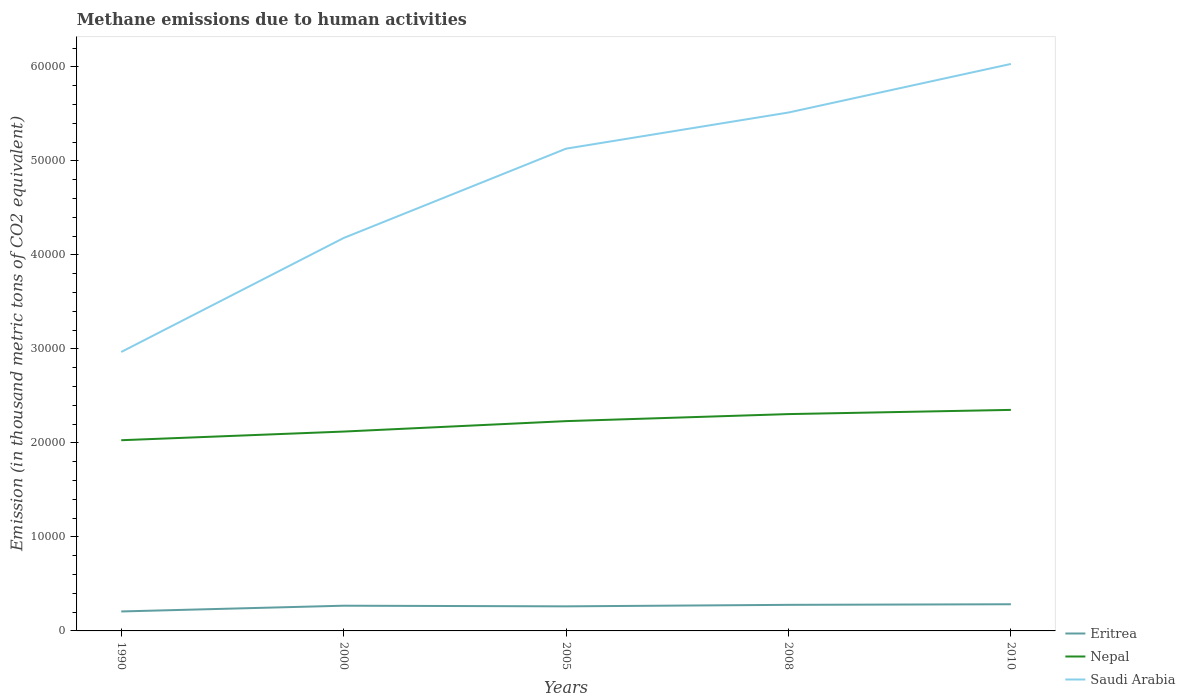How many different coloured lines are there?
Your answer should be compact. 3. Is the number of lines equal to the number of legend labels?
Your answer should be very brief. Yes. Across all years, what is the maximum amount of methane emitted in Eritrea?
Keep it short and to the point. 2070.6. What is the total amount of methane emitted in Saudi Arabia in the graph?
Provide a succinct answer. -1.21e+04. What is the difference between the highest and the second highest amount of methane emitted in Nepal?
Provide a succinct answer. 3226.3. What is the difference between the highest and the lowest amount of methane emitted in Eritrea?
Your answer should be very brief. 4. How many lines are there?
Your response must be concise. 3. What is the difference between two consecutive major ticks on the Y-axis?
Provide a succinct answer. 10000. Does the graph contain any zero values?
Provide a short and direct response. No. How many legend labels are there?
Ensure brevity in your answer.  3. How are the legend labels stacked?
Provide a short and direct response. Vertical. What is the title of the graph?
Make the answer very short. Methane emissions due to human activities. Does "Senegal" appear as one of the legend labels in the graph?
Your answer should be compact. No. What is the label or title of the Y-axis?
Provide a succinct answer. Emission (in thousand metric tons of CO2 equivalent). What is the Emission (in thousand metric tons of CO2 equivalent) in Eritrea in 1990?
Ensure brevity in your answer.  2070.6. What is the Emission (in thousand metric tons of CO2 equivalent) of Nepal in 1990?
Your answer should be compact. 2.03e+04. What is the Emission (in thousand metric tons of CO2 equivalent) of Saudi Arabia in 1990?
Your answer should be very brief. 2.97e+04. What is the Emission (in thousand metric tons of CO2 equivalent) in Eritrea in 2000?
Offer a very short reply. 2682.3. What is the Emission (in thousand metric tons of CO2 equivalent) in Nepal in 2000?
Offer a very short reply. 2.12e+04. What is the Emission (in thousand metric tons of CO2 equivalent) in Saudi Arabia in 2000?
Give a very brief answer. 4.18e+04. What is the Emission (in thousand metric tons of CO2 equivalent) of Eritrea in 2005?
Make the answer very short. 2613.6. What is the Emission (in thousand metric tons of CO2 equivalent) in Nepal in 2005?
Your answer should be very brief. 2.23e+04. What is the Emission (in thousand metric tons of CO2 equivalent) of Saudi Arabia in 2005?
Offer a terse response. 5.13e+04. What is the Emission (in thousand metric tons of CO2 equivalent) of Eritrea in 2008?
Ensure brevity in your answer.  2774.7. What is the Emission (in thousand metric tons of CO2 equivalent) in Nepal in 2008?
Offer a terse response. 2.31e+04. What is the Emission (in thousand metric tons of CO2 equivalent) of Saudi Arabia in 2008?
Your answer should be compact. 5.51e+04. What is the Emission (in thousand metric tons of CO2 equivalent) in Eritrea in 2010?
Offer a very short reply. 2837. What is the Emission (in thousand metric tons of CO2 equivalent) in Nepal in 2010?
Your response must be concise. 2.35e+04. What is the Emission (in thousand metric tons of CO2 equivalent) of Saudi Arabia in 2010?
Your answer should be compact. 6.03e+04. Across all years, what is the maximum Emission (in thousand metric tons of CO2 equivalent) in Eritrea?
Provide a short and direct response. 2837. Across all years, what is the maximum Emission (in thousand metric tons of CO2 equivalent) in Nepal?
Your answer should be compact. 2.35e+04. Across all years, what is the maximum Emission (in thousand metric tons of CO2 equivalent) in Saudi Arabia?
Give a very brief answer. 6.03e+04. Across all years, what is the minimum Emission (in thousand metric tons of CO2 equivalent) in Eritrea?
Ensure brevity in your answer.  2070.6. Across all years, what is the minimum Emission (in thousand metric tons of CO2 equivalent) in Nepal?
Keep it short and to the point. 2.03e+04. Across all years, what is the minimum Emission (in thousand metric tons of CO2 equivalent) in Saudi Arabia?
Your answer should be compact. 2.97e+04. What is the total Emission (in thousand metric tons of CO2 equivalent) of Eritrea in the graph?
Make the answer very short. 1.30e+04. What is the total Emission (in thousand metric tons of CO2 equivalent) in Nepal in the graph?
Make the answer very short. 1.10e+05. What is the total Emission (in thousand metric tons of CO2 equivalent) of Saudi Arabia in the graph?
Your answer should be very brief. 2.38e+05. What is the difference between the Emission (in thousand metric tons of CO2 equivalent) in Eritrea in 1990 and that in 2000?
Provide a short and direct response. -611.7. What is the difference between the Emission (in thousand metric tons of CO2 equivalent) in Nepal in 1990 and that in 2000?
Offer a very short reply. -920.3. What is the difference between the Emission (in thousand metric tons of CO2 equivalent) of Saudi Arabia in 1990 and that in 2000?
Offer a terse response. -1.21e+04. What is the difference between the Emission (in thousand metric tons of CO2 equivalent) of Eritrea in 1990 and that in 2005?
Make the answer very short. -543. What is the difference between the Emission (in thousand metric tons of CO2 equivalent) in Nepal in 1990 and that in 2005?
Provide a succinct answer. -2031.1. What is the difference between the Emission (in thousand metric tons of CO2 equivalent) of Saudi Arabia in 1990 and that in 2005?
Give a very brief answer. -2.16e+04. What is the difference between the Emission (in thousand metric tons of CO2 equivalent) in Eritrea in 1990 and that in 2008?
Keep it short and to the point. -704.1. What is the difference between the Emission (in thousand metric tons of CO2 equivalent) of Nepal in 1990 and that in 2008?
Give a very brief answer. -2778.1. What is the difference between the Emission (in thousand metric tons of CO2 equivalent) of Saudi Arabia in 1990 and that in 2008?
Provide a short and direct response. -2.55e+04. What is the difference between the Emission (in thousand metric tons of CO2 equivalent) of Eritrea in 1990 and that in 2010?
Keep it short and to the point. -766.4. What is the difference between the Emission (in thousand metric tons of CO2 equivalent) in Nepal in 1990 and that in 2010?
Give a very brief answer. -3226.3. What is the difference between the Emission (in thousand metric tons of CO2 equivalent) of Saudi Arabia in 1990 and that in 2010?
Your answer should be compact. -3.06e+04. What is the difference between the Emission (in thousand metric tons of CO2 equivalent) in Eritrea in 2000 and that in 2005?
Ensure brevity in your answer.  68.7. What is the difference between the Emission (in thousand metric tons of CO2 equivalent) in Nepal in 2000 and that in 2005?
Provide a succinct answer. -1110.8. What is the difference between the Emission (in thousand metric tons of CO2 equivalent) of Saudi Arabia in 2000 and that in 2005?
Ensure brevity in your answer.  -9501.6. What is the difference between the Emission (in thousand metric tons of CO2 equivalent) in Eritrea in 2000 and that in 2008?
Make the answer very short. -92.4. What is the difference between the Emission (in thousand metric tons of CO2 equivalent) of Nepal in 2000 and that in 2008?
Ensure brevity in your answer.  -1857.8. What is the difference between the Emission (in thousand metric tons of CO2 equivalent) of Saudi Arabia in 2000 and that in 2008?
Offer a terse response. -1.33e+04. What is the difference between the Emission (in thousand metric tons of CO2 equivalent) in Eritrea in 2000 and that in 2010?
Offer a terse response. -154.7. What is the difference between the Emission (in thousand metric tons of CO2 equivalent) in Nepal in 2000 and that in 2010?
Offer a terse response. -2306. What is the difference between the Emission (in thousand metric tons of CO2 equivalent) in Saudi Arabia in 2000 and that in 2010?
Give a very brief answer. -1.85e+04. What is the difference between the Emission (in thousand metric tons of CO2 equivalent) in Eritrea in 2005 and that in 2008?
Your response must be concise. -161.1. What is the difference between the Emission (in thousand metric tons of CO2 equivalent) of Nepal in 2005 and that in 2008?
Provide a short and direct response. -747. What is the difference between the Emission (in thousand metric tons of CO2 equivalent) of Saudi Arabia in 2005 and that in 2008?
Give a very brief answer. -3844.6. What is the difference between the Emission (in thousand metric tons of CO2 equivalent) in Eritrea in 2005 and that in 2010?
Offer a terse response. -223.4. What is the difference between the Emission (in thousand metric tons of CO2 equivalent) in Nepal in 2005 and that in 2010?
Offer a terse response. -1195.2. What is the difference between the Emission (in thousand metric tons of CO2 equivalent) in Saudi Arabia in 2005 and that in 2010?
Your answer should be compact. -9011.1. What is the difference between the Emission (in thousand metric tons of CO2 equivalent) in Eritrea in 2008 and that in 2010?
Your response must be concise. -62.3. What is the difference between the Emission (in thousand metric tons of CO2 equivalent) in Nepal in 2008 and that in 2010?
Your answer should be compact. -448.2. What is the difference between the Emission (in thousand metric tons of CO2 equivalent) in Saudi Arabia in 2008 and that in 2010?
Make the answer very short. -5166.5. What is the difference between the Emission (in thousand metric tons of CO2 equivalent) in Eritrea in 1990 and the Emission (in thousand metric tons of CO2 equivalent) in Nepal in 2000?
Give a very brief answer. -1.91e+04. What is the difference between the Emission (in thousand metric tons of CO2 equivalent) of Eritrea in 1990 and the Emission (in thousand metric tons of CO2 equivalent) of Saudi Arabia in 2000?
Ensure brevity in your answer.  -3.97e+04. What is the difference between the Emission (in thousand metric tons of CO2 equivalent) of Nepal in 1990 and the Emission (in thousand metric tons of CO2 equivalent) of Saudi Arabia in 2000?
Your response must be concise. -2.15e+04. What is the difference between the Emission (in thousand metric tons of CO2 equivalent) in Eritrea in 1990 and the Emission (in thousand metric tons of CO2 equivalent) in Nepal in 2005?
Offer a terse response. -2.02e+04. What is the difference between the Emission (in thousand metric tons of CO2 equivalent) of Eritrea in 1990 and the Emission (in thousand metric tons of CO2 equivalent) of Saudi Arabia in 2005?
Keep it short and to the point. -4.92e+04. What is the difference between the Emission (in thousand metric tons of CO2 equivalent) in Nepal in 1990 and the Emission (in thousand metric tons of CO2 equivalent) in Saudi Arabia in 2005?
Provide a succinct answer. -3.10e+04. What is the difference between the Emission (in thousand metric tons of CO2 equivalent) in Eritrea in 1990 and the Emission (in thousand metric tons of CO2 equivalent) in Nepal in 2008?
Make the answer very short. -2.10e+04. What is the difference between the Emission (in thousand metric tons of CO2 equivalent) of Eritrea in 1990 and the Emission (in thousand metric tons of CO2 equivalent) of Saudi Arabia in 2008?
Your answer should be compact. -5.31e+04. What is the difference between the Emission (in thousand metric tons of CO2 equivalent) of Nepal in 1990 and the Emission (in thousand metric tons of CO2 equivalent) of Saudi Arabia in 2008?
Keep it short and to the point. -3.49e+04. What is the difference between the Emission (in thousand metric tons of CO2 equivalent) in Eritrea in 1990 and the Emission (in thousand metric tons of CO2 equivalent) in Nepal in 2010?
Ensure brevity in your answer.  -2.14e+04. What is the difference between the Emission (in thousand metric tons of CO2 equivalent) in Eritrea in 1990 and the Emission (in thousand metric tons of CO2 equivalent) in Saudi Arabia in 2010?
Provide a short and direct response. -5.82e+04. What is the difference between the Emission (in thousand metric tons of CO2 equivalent) in Nepal in 1990 and the Emission (in thousand metric tons of CO2 equivalent) in Saudi Arabia in 2010?
Ensure brevity in your answer.  -4.00e+04. What is the difference between the Emission (in thousand metric tons of CO2 equivalent) in Eritrea in 2000 and the Emission (in thousand metric tons of CO2 equivalent) in Nepal in 2005?
Give a very brief answer. -1.96e+04. What is the difference between the Emission (in thousand metric tons of CO2 equivalent) of Eritrea in 2000 and the Emission (in thousand metric tons of CO2 equivalent) of Saudi Arabia in 2005?
Offer a very short reply. -4.86e+04. What is the difference between the Emission (in thousand metric tons of CO2 equivalent) of Nepal in 2000 and the Emission (in thousand metric tons of CO2 equivalent) of Saudi Arabia in 2005?
Provide a short and direct response. -3.01e+04. What is the difference between the Emission (in thousand metric tons of CO2 equivalent) in Eritrea in 2000 and the Emission (in thousand metric tons of CO2 equivalent) in Nepal in 2008?
Offer a very short reply. -2.04e+04. What is the difference between the Emission (in thousand metric tons of CO2 equivalent) in Eritrea in 2000 and the Emission (in thousand metric tons of CO2 equivalent) in Saudi Arabia in 2008?
Make the answer very short. -5.25e+04. What is the difference between the Emission (in thousand metric tons of CO2 equivalent) of Nepal in 2000 and the Emission (in thousand metric tons of CO2 equivalent) of Saudi Arabia in 2008?
Provide a succinct answer. -3.39e+04. What is the difference between the Emission (in thousand metric tons of CO2 equivalent) in Eritrea in 2000 and the Emission (in thousand metric tons of CO2 equivalent) in Nepal in 2010?
Ensure brevity in your answer.  -2.08e+04. What is the difference between the Emission (in thousand metric tons of CO2 equivalent) in Eritrea in 2000 and the Emission (in thousand metric tons of CO2 equivalent) in Saudi Arabia in 2010?
Offer a terse response. -5.76e+04. What is the difference between the Emission (in thousand metric tons of CO2 equivalent) of Nepal in 2000 and the Emission (in thousand metric tons of CO2 equivalent) of Saudi Arabia in 2010?
Keep it short and to the point. -3.91e+04. What is the difference between the Emission (in thousand metric tons of CO2 equivalent) of Eritrea in 2005 and the Emission (in thousand metric tons of CO2 equivalent) of Nepal in 2008?
Give a very brief answer. -2.05e+04. What is the difference between the Emission (in thousand metric tons of CO2 equivalent) of Eritrea in 2005 and the Emission (in thousand metric tons of CO2 equivalent) of Saudi Arabia in 2008?
Your answer should be very brief. -5.25e+04. What is the difference between the Emission (in thousand metric tons of CO2 equivalent) of Nepal in 2005 and the Emission (in thousand metric tons of CO2 equivalent) of Saudi Arabia in 2008?
Give a very brief answer. -3.28e+04. What is the difference between the Emission (in thousand metric tons of CO2 equivalent) in Eritrea in 2005 and the Emission (in thousand metric tons of CO2 equivalent) in Nepal in 2010?
Your answer should be compact. -2.09e+04. What is the difference between the Emission (in thousand metric tons of CO2 equivalent) of Eritrea in 2005 and the Emission (in thousand metric tons of CO2 equivalent) of Saudi Arabia in 2010?
Provide a short and direct response. -5.77e+04. What is the difference between the Emission (in thousand metric tons of CO2 equivalent) of Nepal in 2005 and the Emission (in thousand metric tons of CO2 equivalent) of Saudi Arabia in 2010?
Your answer should be very brief. -3.80e+04. What is the difference between the Emission (in thousand metric tons of CO2 equivalent) in Eritrea in 2008 and the Emission (in thousand metric tons of CO2 equivalent) in Nepal in 2010?
Offer a very short reply. -2.07e+04. What is the difference between the Emission (in thousand metric tons of CO2 equivalent) of Eritrea in 2008 and the Emission (in thousand metric tons of CO2 equivalent) of Saudi Arabia in 2010?
Make the answer very short. -5.75e+04. What is the difference between the Emission (in thousand metric tons of CO2 equivalent) of Nepal in 2008 and the Emission (in thousand metric tons of CO2 equivalent) of Saudi Arabia in 2010?
Your answer should be compact. -3.72e+04. What is the average Emission (in thousand metric tons of CO2 equivalent) in Eritrea per year?
Your answer should be compact. 2595.64. What is the average Emission (in thousand metric tons of CO2 equivalent) in Nepal per year?
Provide a succinct answer. 2.21e+04. What is the average Emission (in thousand metric tons of CO2 equivalent) in Saudi Arabia per year?
Your answer should be compact. 4.76e+04. In the year 1990, what is the difference between the Emission (in thousand metric tons of CO2 equivalent) of Eritrea and Emission (in thousand metric tons of CO2 equivalent) of Nepal?
Make the answer very short. -1.82e+04. In the year 1990, what is the difference between the Emission (in thousand metric tons of CO2 equivalent) in Eritrea and Emission (in thousand metric tons of CO2 equivalent) in Saudi Arabia?
Ensure brevity in your answer.  -2.76e+04. In the year 1990, what is the difference between the Emission (in thousand metric tons of CO2 equivalent) of Nepal and Emission (in thousand metric tons of CO2 equivalent) of Saudi Arabia?
Your answer should be compact. -9386.3. In the year 2000, what is the difference between the Emission (in thousand metric tons of CO2 equivalent) in Eritrea and Emission (in thousand metric tons of CO2 equivalent) in Nepal?
Your response must be concise. -1.85e+04. In the year 2000, what is the difference between the Emission (in thousand metric tons of CO2 equivalent) of Eritrea and Emission (in thousand metric tons of CO2 equivalent) of Saudi Arabia?
Give a very brief answer. -3.91e+04. In the year 2000, what is the difference between the Emission (in thousand metric tons of CO2 equivalent) of Nepal and Emission (in thousand metric tons of CO2 equivalent) of Saudi Arabia?
Give a very brief answer. -2.06e+04. In the year 2005, what is the difference between the Emission (in thousand metric tons of CO2 equivalent) in Eritrea and Emission (in thousand metric tons of CO2 equivalent) in Nepal?
Your answer should be very brief. -1.97e+04. In the year 2005, what is the difference between the Emission (in thousand metric tons of CO2 equivalent) of Eritrea and Emission (in thousand metric tons of CO2 equivalent) of Saudi Arabia?
Provide a succinct answer. -4.87e+04. In the year 2005, what is the difference between the Emission (in thousand metric tons of CO2 equivalent) of Nepal and Emission (in thousand metric tons of CO2 equivalent) of Saudi Arabia?
Give a very brief answer. -2.90e+04. In the year 2008, what is the difference between the Emission (in thousand metric tons of CO2 equivalent) of Eritrea and Emission (in thousand metric tons of CO2 equivalent) of Nepal?
Give a very brief answer. -2.03e+04. In the year 2008, what is the difference between the Emission (in thousand metric tons of CO2 equivalent) of Eritrea and Emission (in thousand metric tons of CO2 equivalent) of Saudi Arabia?
Give a very brief answer. -5.24e+04. In the year 2008, what is the difference between the Emission (in thousand metric tons of CO2 equivalent) of Nepal and Emission (in thousand metric tons of CO2 equivalent) of Saudi Arabia?
Offer a terse response. -3.21e+04. In the year 2010, what is the difference between the Emission (in thousand metric tons of CO2 equivalent) in Eritrea and Emission (in thousand metric tons of CO2 equivalent) in Nepal?
Keep it short and to the point. -2.07e+04. In the year 2010, what is the difference between the Emission (in thousand metric tons of CO2 equivalent) in Eritrea and Emission (in thousand metric tons of CO2 equivalent) in Saudi Arabia?
Offer a terse response. -5.75e+04. In the year 2010, what is the difference between the Emission (in thousand metric tons of CO2 equivalent) of Nepal and Emission (in thousand metric tons of CO2 equivalent) of Saudi Arabia?
Ensure brevity in your answer.  -3.68e+04. What is the ratio of the Emission (in thousand metric tons of CO2 equivalent) in Eritrea in 1990 to that in 2000?
Make the answer very short. 0.77. What is the ratio of the Emission (in thousand metric tons of CO2 equivalent) in Nepal in 1990 to that in 2000?
Keep it short and to the point. 0.96. What is the ratio of the Emission (in thousand metric tons of CO2 equivalent) in Saudi Arabia in 1990 to that in 2000?
Provide a short and direct response. 0.71. What is the ratio of the Emission (in thousand metric tons of CO2 equivalent) in Eritrea in 1990 to that in 2005?
Give a very brief answer. 0.79. What is the ratio of the Emission (in thousand metric tons of CO2 equivalent) in Nepal in 1990 to that in 2005?
Make the answer very short. 0.91. What is the ratio of the Emission (in thousand metric tons of CO2 equivalent) of Saudi Arabia in 1990 to that in 2005?
Your response must be concise. 0.58. What is the ratio of the Emission (in thousand metric tons of CO2 equivalent) in Eritrea in 1990 to that in 2008?
Your answer should be very brief. 0.75. What is the ratio of the Emission (in thousand metric tons of CO2 equivalent) of Nepal in 1990 to that in 2008?
Make the answer very short. 0.88. What is the ratio of the Emission (in thousand metric tons of CO2 equivalent) of Saudi Arabia in 1990 to that in 2008?
Make the answer very short. 0.54. What is the ratio of the Emission (in thousand metric tons of CO2 equivalent) in Eritrea in 1990 to that in 2010?
Your answer should be very brief. 0.73. What is the ratio of the Emission (in thousand metric tons of CO2 equivalent) in Nepal in 1990 to that in 2010?
Keep it short and to the point. 0.86. What is the ratio of the Emission (in thousand metric tons of CO2 equivalent) of Saudi Arabia in 1990 to that in 2010?
Keep it short and to the point. 0.49. What is the ratio of the Emission (in thousand metric tons of CO2 equivalent) in Eritrea in 2000 to that in 2005?
Your answer should be very brief. 1.03. What is the ratio of the Emission (in thousand metric tons of CO2 equivalent) in Nepal in 2000 to that in 2005?
Offer a very short reply. 0.95. What is the ratio of the Emission (in thousand metric tons of CO2 equivalent) in Saudi Arabia in 2000 to that in 2005?
Give a very brief answer. 0.81. What is the ratio of the Emission (in thousand metric tons of CO2 equivalent) of Eritrea in 2000 to that in 2008?
Your response must be concise. 0.97. What is the ratio of the Emission (in thousand metric tons of CO2 equivalent) in Nepal in 2000 to that in 2008?
Provide a succinct answer. 0.92. What is the ratio of the Emission (in thousand metric tons of CO2 equivalent) in Saudi Arabia in 2000 to that in 2008?
Your answer should be compact. 0.76. What is the ratio of the Emission (in thousand metric tons of CO2 equivalent) in Eritrea in 2000 to that in 2010?
Provide a short and direct response. 0.95. What is the ratio of the Emission (in thousand metric tons of CO2 equivalent) in Nepal in 2000 to that in 2010?
Offer a very short reply. 0.9. What is the ratio of the Emission (in thousand metric tons of CO2 equivalent) in Saudi Arabia in 2000 to that in 2010?
Give a very brief answer. 0.69. What is the ratio of the Emission (in thousand metric tons of CO2 equivalent) of Eritrea in 2005 to that in 2008?
Provide a succinct answer. 0.94. What is the ratio of the Emission (in thousand metric tons of CO2 equivalent) in Nepal in 2005 to that in 2008?
Your response must be concise. 0.97. What is the ratio of the Emission (in thousand metric tons of CO2 equivalent) in Saudi Arabia in 2005 to that in 2008?
Your answer should be very brief. 0.93. What is the ratio of the Emission (in thousand metric tons of CO2 equivalent) of Eritrea in 2005 to that in 2010?
Your response must be concise. 0.92. What is the ratio of the Emission (in thousand metric tons of CO2 equivalent) in Nepal in 2005 to that in 2010?
Offer a very short reply. 0.95. What is the ratio of the Emission (in thousand metric tons of CO2 equivalent) in Saudi Arabia in 2005 to that in 2010?
Your response must be concise. 0.85. What is the ratio of the Emission (in thousand metric tons of CO2 equivalent) of Eritrea in 2008 to that in 2010?
Ensure brevity in your answer.  0.98. What is the ratio of the Emission (in thousand metric tons of CO2 equivalent) in Nepal in 2008 to that in 2010?
Offer a terse response. 0.98. What is the ratio of the Emission (in thousand metric tons of CO2 equivalent) in Saudi Arabia in 2008 to that in 2010?
Your answer should be compact. 0.91. What is the difference between the highest and the second highest Emission (in thousand metric tons of CO2 equivalent) of Eritrea?
Ensure brevity in your answer.  62.3. What is the difference between the highest and the second highest Emission (in thousand metric tons of CO2 equivalent) of Nepal?
Your answer should be compact. 448.2. What is the difference between the highest and the second highest Emission (in thousand metric tons of CO2 equivalent) in Saudi Arabia?
Provide a succinct answer. 5166.5. What is the difference between the highest and the lowest Emission (in thousand metric tons of CO2 equivalent) in Eritrea?
Offer a terse response. 766.4. What is the difference between the highest and the lowest Emission (in thousand metric tons of CO2 equivalent) in Nepal?
Provide a succinct answer. 3226.3. What is the difference between the highest and the lowest Emission (in thousand metric tons of CO2 equivalent) of Saudi Arabia?
Provide a short and direct response. 3.06e+04. 